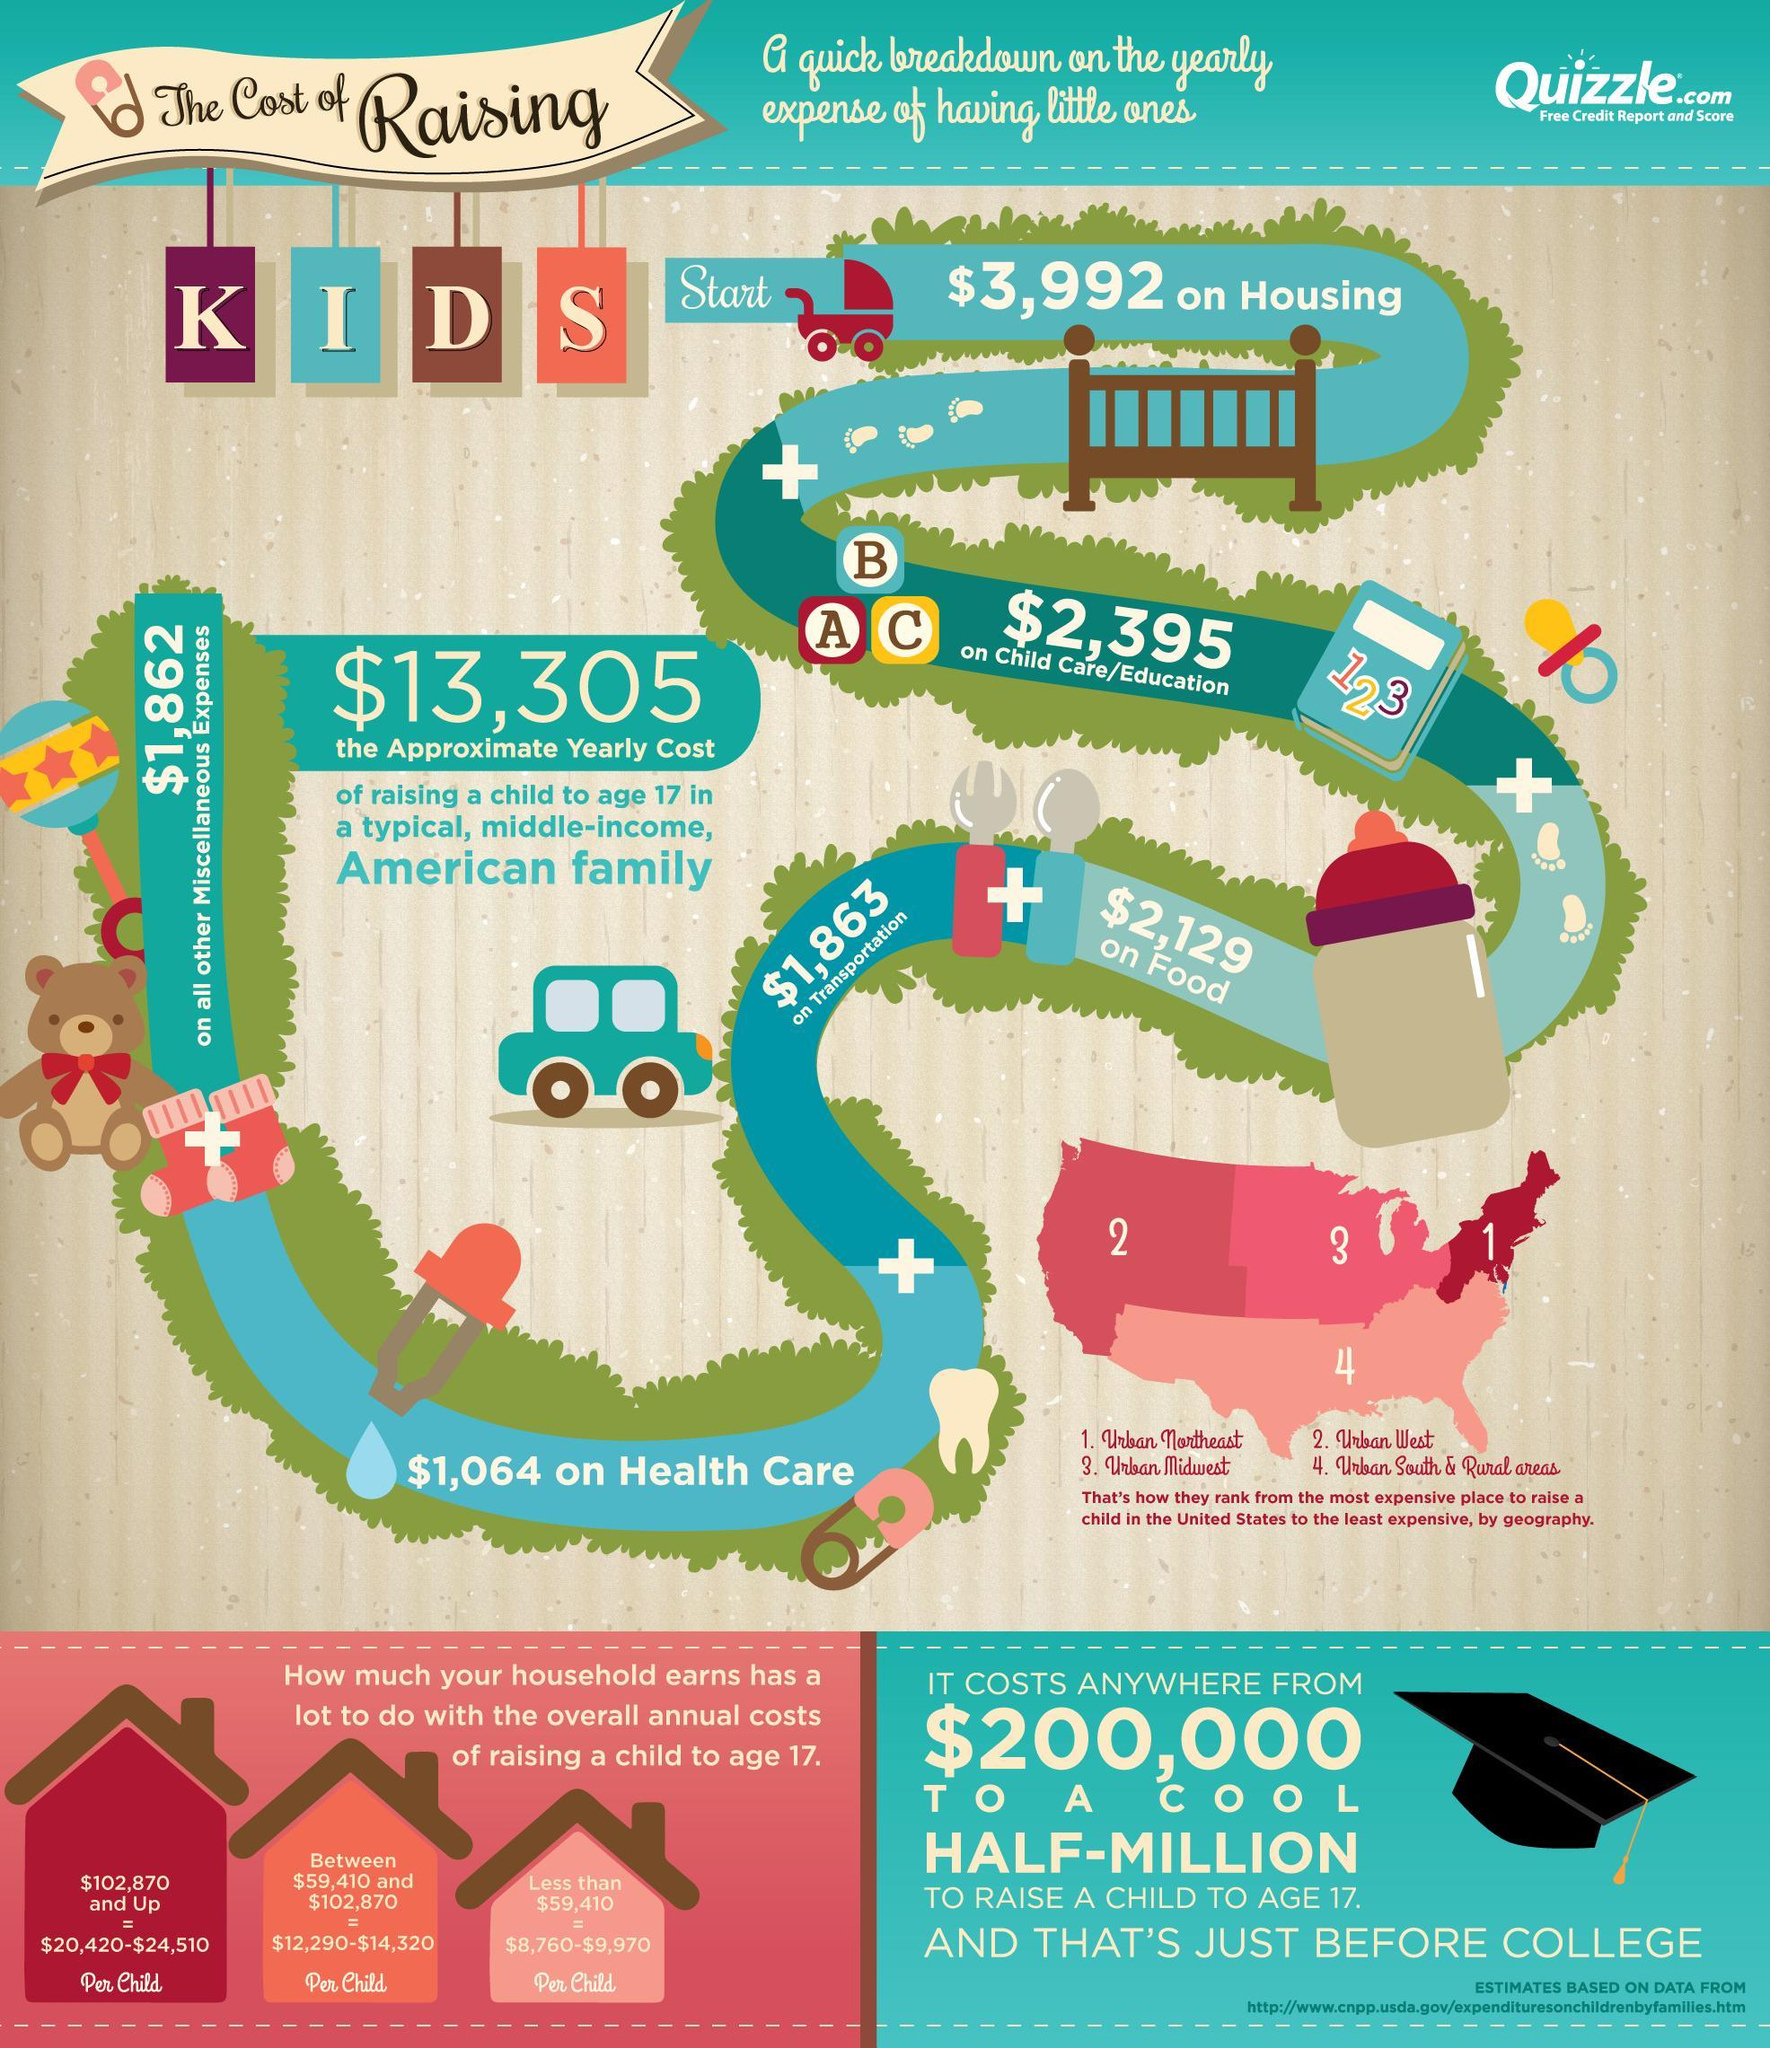What is the approximate yearly cost for child care/education for a child in a typical, middle-income, American Family?
Answer the question with a short phrase. $2,395 What is the approximate yearly cost for housing for a child in a typical, middle-income, American Family? $3,992 What is the approximate yearly cost of raising a child to age 17 in a typical, middle-income, American Family? $13,305 What is the approximate yearly cost for transportation for a child in a typical, middle-income, American Family? $1,863 What is the approximate yearly cost for health care for a child in a typical, middle-income, American Family? $1,064 What is the approximate yearly cost for food for a child in a typical, middle-income, American Family? $2,129 